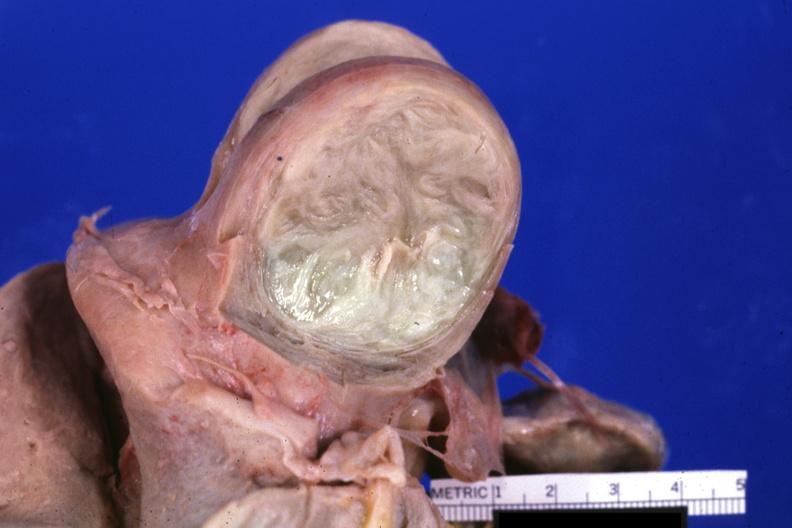s uterus present?
Answer the question using a single word or phrase. Yes 